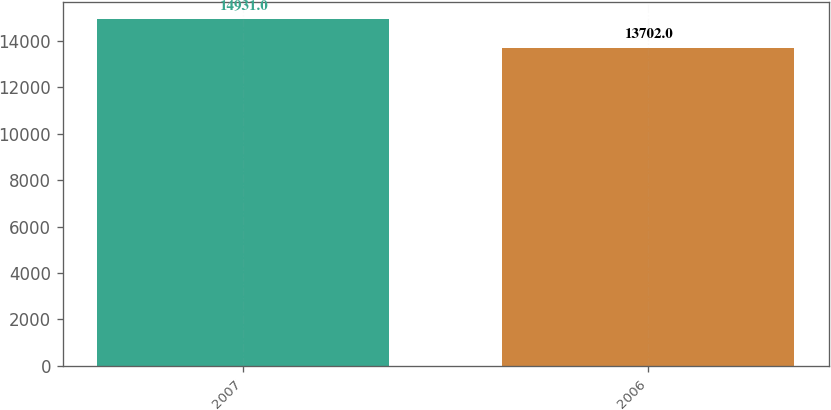<chart> <loc_0><loc_0><loc_500><loc_500><bar_chart><fcel>2007<fcel>2006<nl><fcel>14931<fcel>13702<nl></chart> 